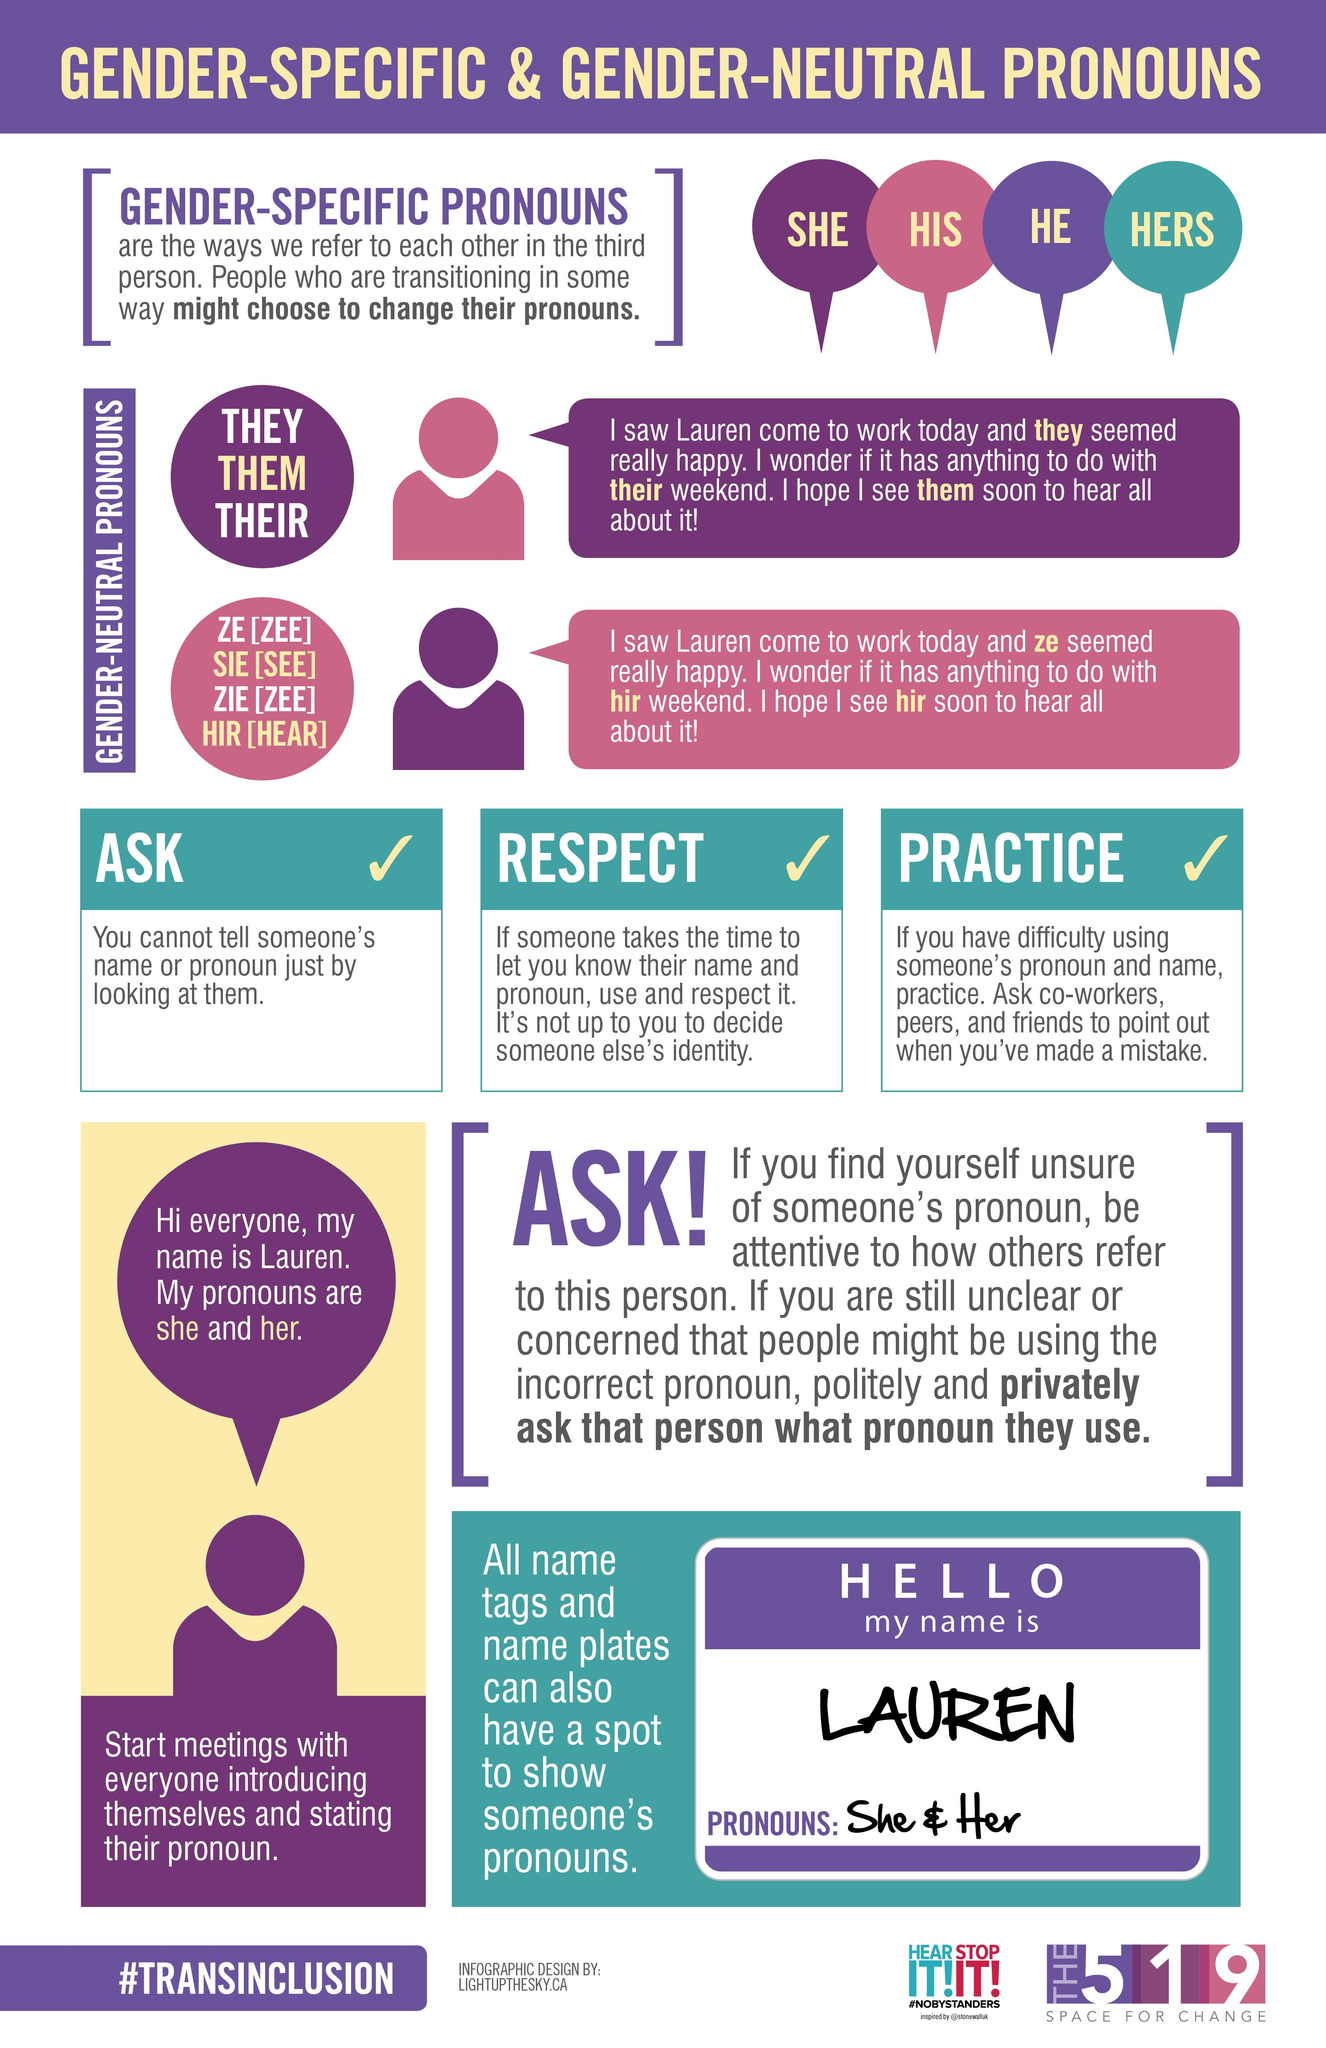Highlight a few significant elements in this photo. The name tag shows the pronouns "she" and "her. There are a variety of gender-specific pronouns, such as "his," "he," and "hers," in addition to "she. In the purple circle, the gender-neutral pronouns are 'they', 'them', and 'their'. 